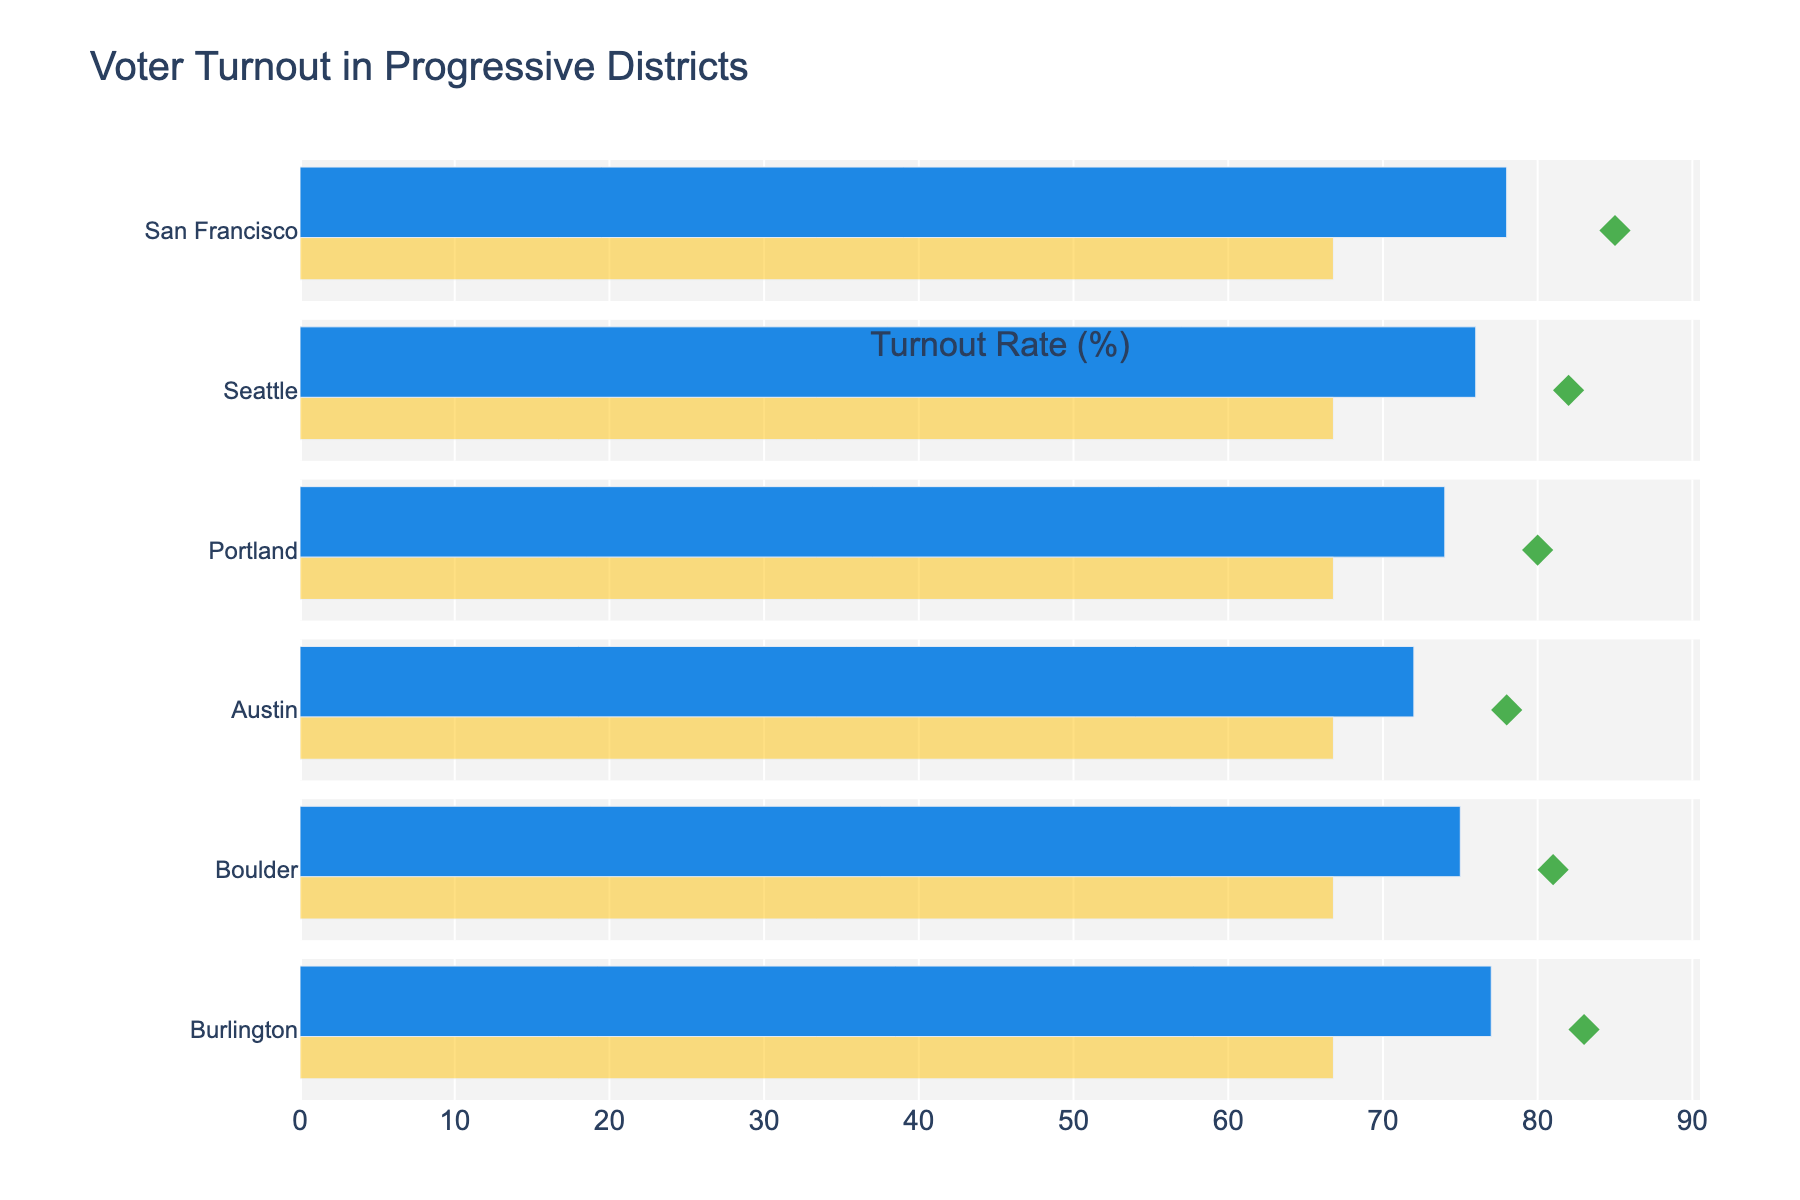What's the title of the figure? The title is usually found at the top of the figure. In this case, it is clearly mentioned at the top.
Answer: Voter Turnout in Progressive Districts How many districts are compared in the figure? Count the number of distinct bars or entries listed on the y-axis.
Answer: 6 Which district has the highest actual voter turnout? Look at the bars representing the 'Actual Turnout' and identify the highest one.
Answer: San Francisco What is the target voter turnout for Seattle? Locate the diamond marker for Seattle along the x-axis, which represents the target turnout rate.
Answer: 82 Compare the actual voter turnout of Portland and Austin. Which one is higher? Look at the respective bars for 'Actual Turnout' for Portland and Austin, then compare their lengths.
Answer: Portland What is the difference between the national average turnout and the target turnout for Boulder? Subtract the national average value (66.8) from the target turnout for Boulder (81).
Answer: 14.2 Which district has an actual voter turnout closest to its target? Determine the difference between 'Actual Turnout' and 'Target' for each district, and find the smallest difference.
Answer: Burlington How much lower is Austin's actual voter turnout compared to its target? Subtract the actual turnout of Austin (72) from its target turnout (78).
Answer: 6 What is the range of the turnout rates shown on the x-axis? Look at the axis labeled 'Turnout Rate (%)' to identify the minimum and maximum values displayed.
Answer: 60 to 90 Does any district meet or exceed its target voter turnout? Compare the 'Actual Turnout' with the 'Target' for each district to check if any district's actual turnout is equal to or greater than its target.
Answer: No 